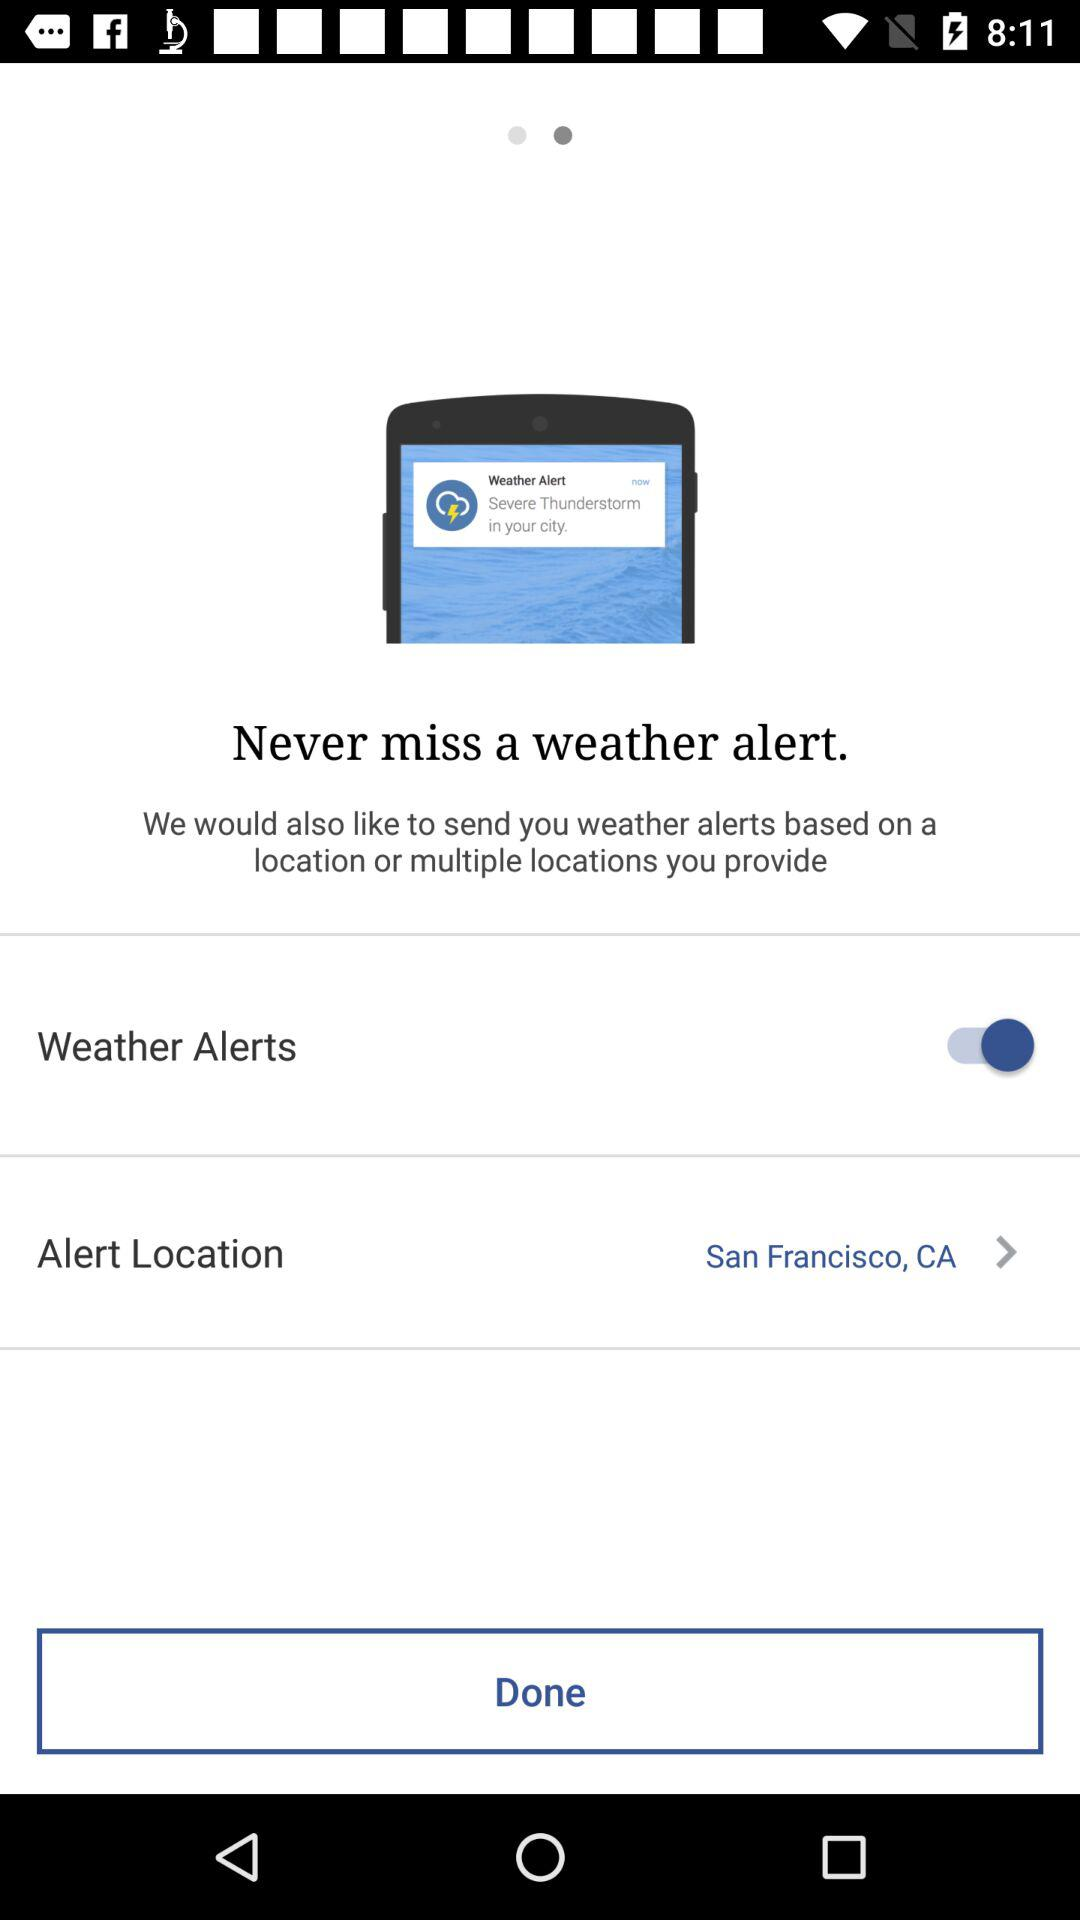What is the alert location? The alert location is San Francisco, CA. 